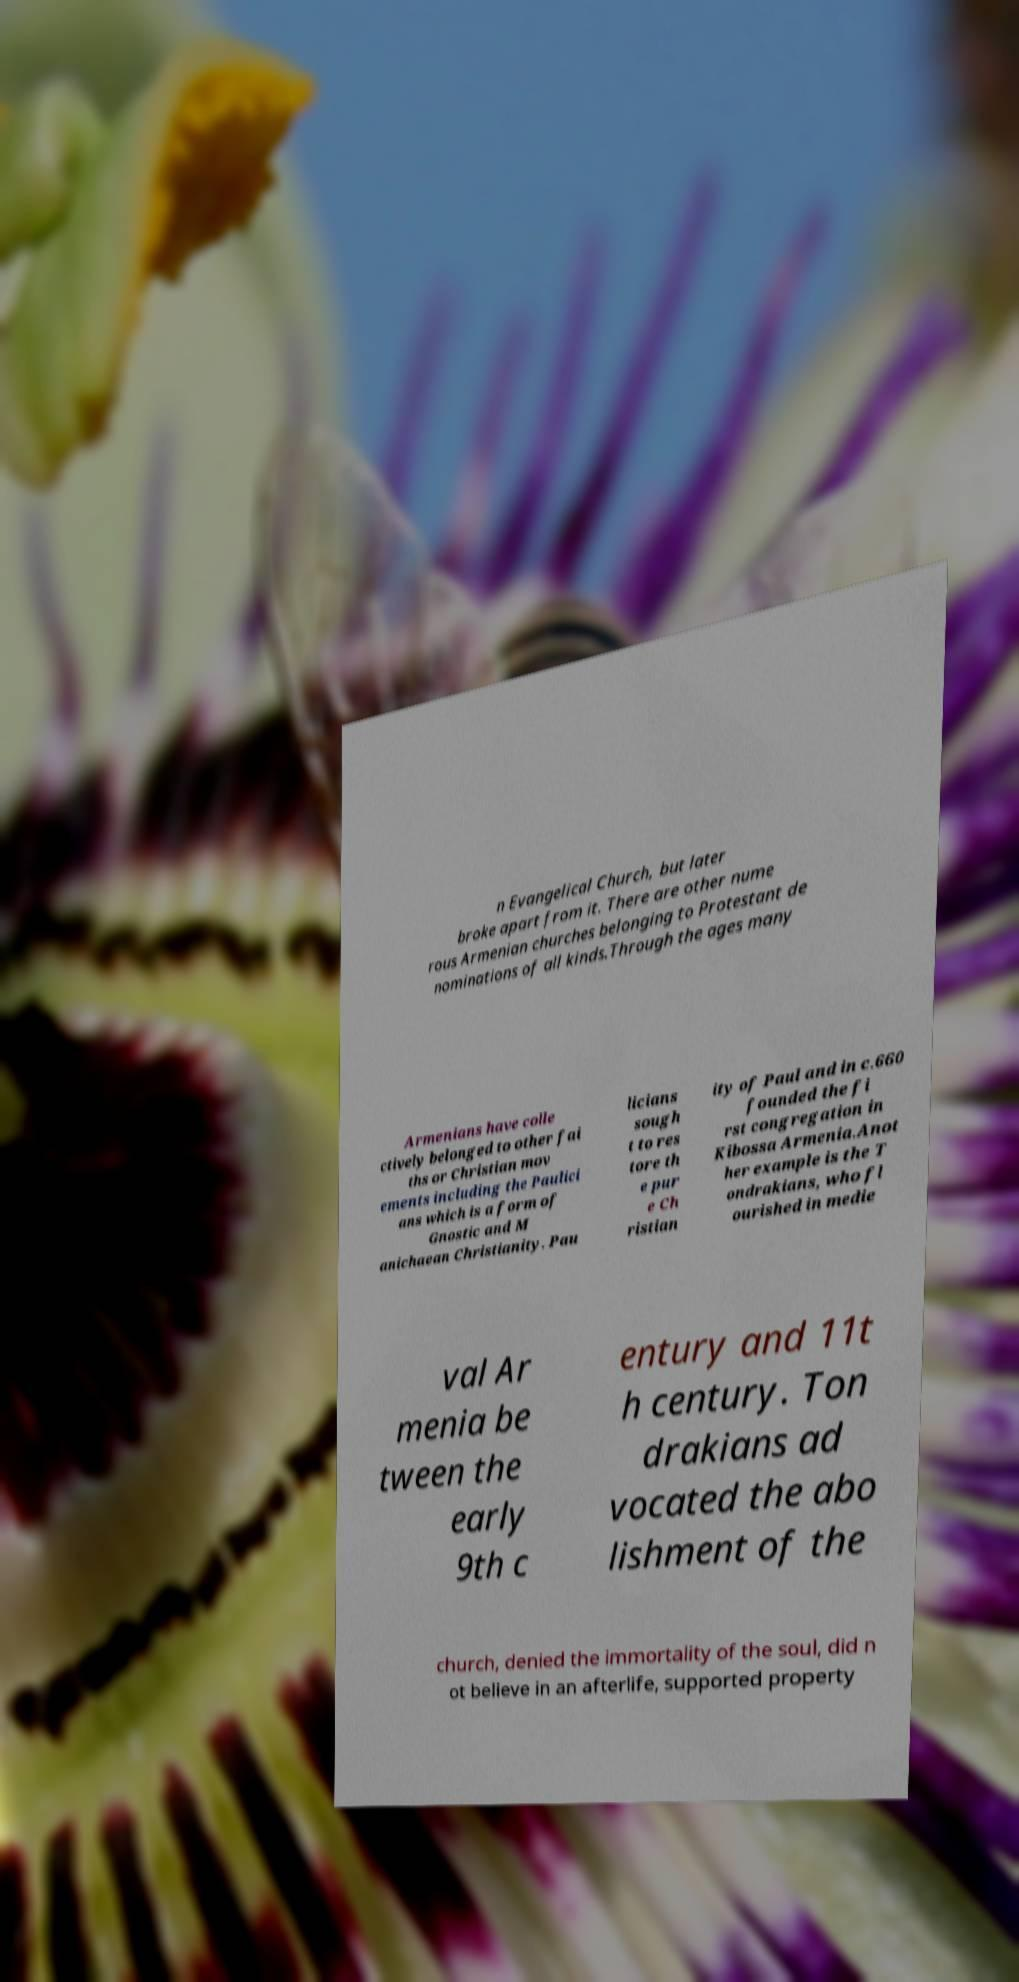I need the written content from this picture converted into text. Can you do that? n Evangelical Church, but later broke apart from it. There are other nume rous Armenian churches belonging to Protestant de nominations of all kinds.Through the ages many Armenians have colle ctively belonged to other fai ths or Christian mov ements including the Paulici ans which is a form of Gnostic and M anichaean Christianity. Pau licians sough t to res tore th e pur e Ch ristian ity of Paul and in c.660 founded the fi rst congregation in Kibossa Armenia.Anot her example is the T ondrakians, who fl ourished in medie val Ar menia be tween the early 9th c entury and 11t h century. Ton drakians ad vocated the abo lishment of the church, denied the immortality of the soul, did n ot believe in an afterlife, supported property 